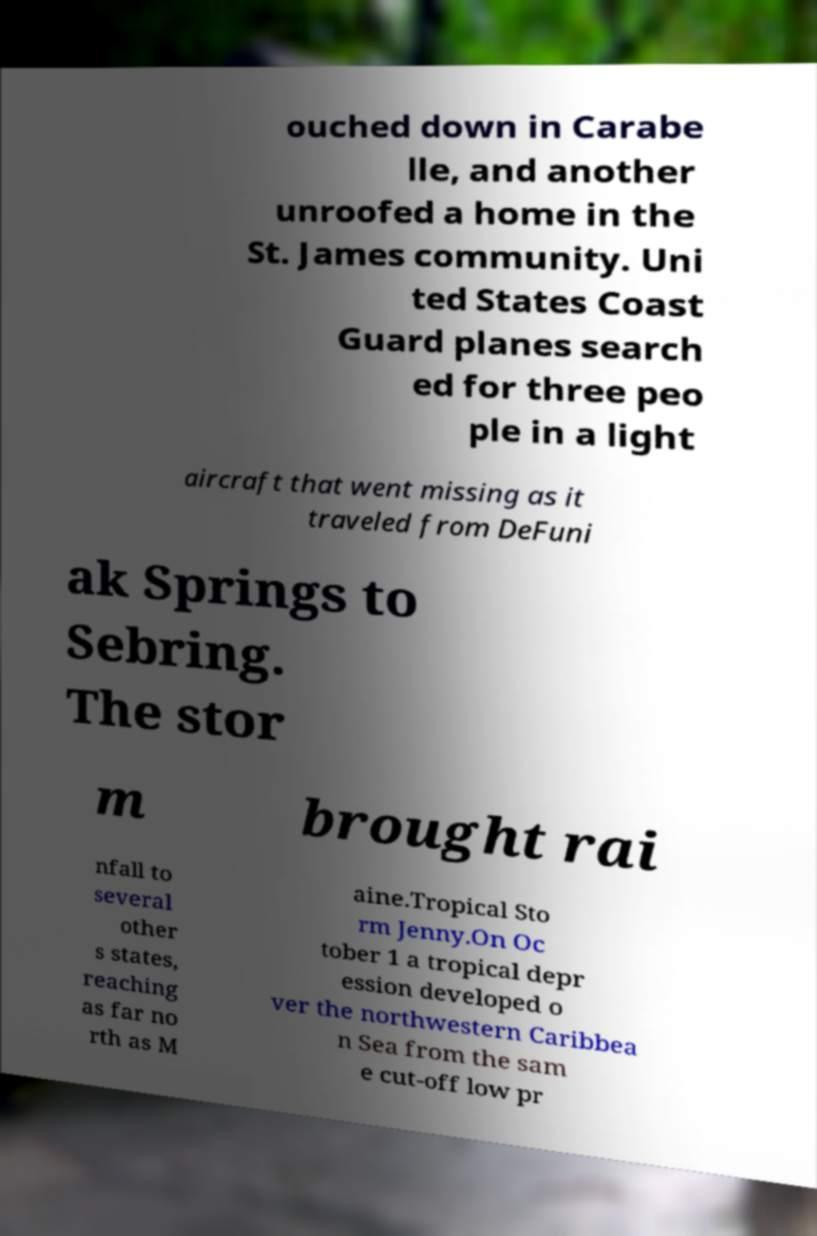Can you accurately transcribe the text from the provided image for me? ouched down in Carabe lle, and another unroofed a home in the St. James community. Uni ted States Coast Guard planes search ed for three peo ple in a light aircraft that went missing as it traveled from DeFuni ak Springs to Sebring. The stor m brought rai nfall to several other s states, reaching as far no rth as M aine.Tropical Sto rm Jenny.On Oc tober 1 a tropical depr ession developed o ver the northwestern Caribbea n Sea from the sam e cut-off low pr 